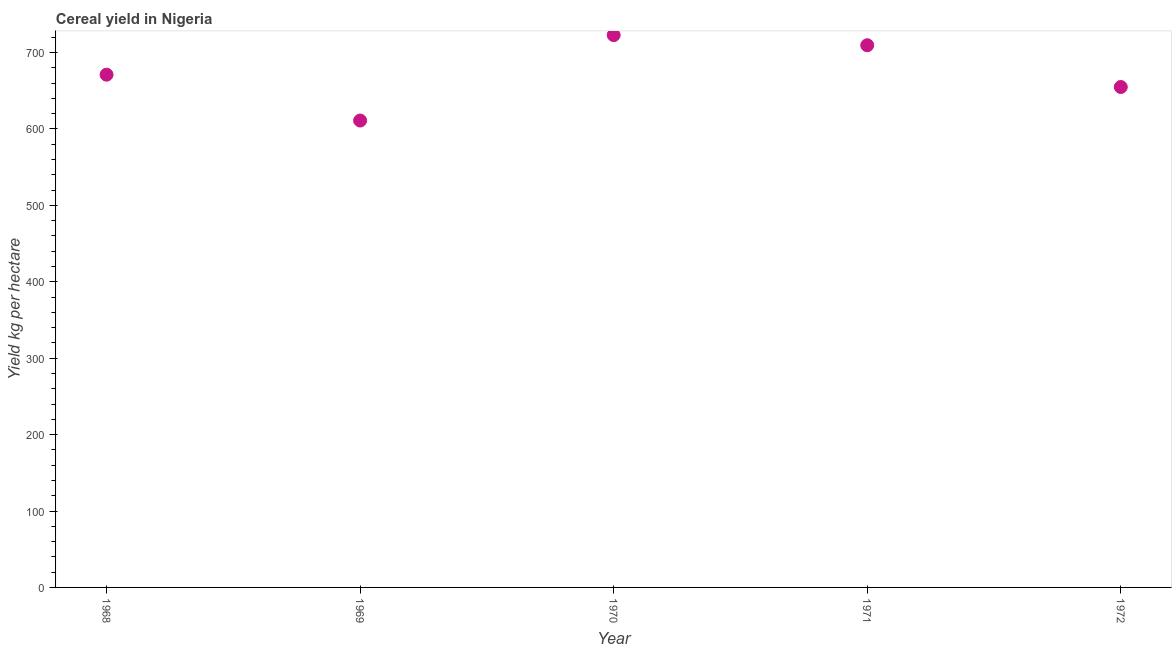What is the cereal yield in 1970?
Keep it short and to the point. 722.88. Across all years, what is the maximum cereal yield?
Provide a succinct answer. 722.88. Across all years, what is the minimum cereal yield?
Offer a terse response. 611.04. In which year was the cereal yield minimum?
Offer a terse response. 1969. What is the sum of the cereal yield?
Your answer should be very brief. 3369.51. What is the difference between the cereal yield in 1968 and 1970?
Provide a short and direct response. -51.8. What is the average cereal yield per year?
Your response must be concise. 673.9. What is the median cereal yield?
Your answer should be very brief. 671.08. Do a majority of the years between 1970 and 1972 (inclusive) have cereal yield greater than 520 kg per hectare?
Provide a short and direct response. Yes. What is the ratio of the cereal yield in 1968 to that in 1969?
Ensure brevity in your answer.  1.1. Is the cereal yield in 1970 less than that in 1972?
Your answer should be very brief. No. Is the difference between the cereal yield in 1971 and 1972 greater than the difference between any two years?
Make the answer very short. No. What is the difference between the highest and the second highest cereal yield?
Ensure brevity in your answer.  13.29. Is the sum of the cereal yield in 1969 and 1970 greater than the maximum cereal yield across all years?
Offer a very short reply. Yes. What is the difference between the highest and the lowest cereal yield?
Your answer should be compact. 111.83. In how many years, is the cereal yield greater than the average cereal yield taken over all years?
Your answer should be compact. 2. Does the cereal yield monotonically increase over the years?
Your answer should be very brief. No. How many years are there in the graph?
Give a very brief answer. 5. What is the difference between two consecutive major ticks on the Y-axis?
Your answer should be compact. 100. Are the values on the major ticks of Y-axis written in scientific E-notation?
Provide a short and direct response. No. Does the graph contain any zero values?
Ensure brevity in your answer.  No. Does the graph contain grids?
Provide a succinct answer. No. What is the title of the graph?
Your answer should be very brief. Cereal yield in Nigeria. What is the label or title of the X-axis?
Your answer should be compact. Year. What is the label or title of the Y-axis?
Your answer should be compact. Yield kg per hectare. What is the Yield kg per hectare in 1968?
Provide a short and direct response. 671.08. What is the Yield kg per hectare in 1969?
Your response must be concise. 611.04. What is the Yield kg per hectare in 1970?
Your response must be concise. 722.88. What is the Yield kg per hectare in 1971?
Ensure brevity in your answer.  709.58. What is the Yield kg per hectare in 1972?
Offer a very short reply. 654.94. What is the difference between the Yield kg per hectare in 1968 and 1969?
Offer a terse response. 60.03. What is the difference between the Yield kg per hectare in 1968 and 1970?
Your answer should be compact. -51.8. What is the difference between the Yield kg per hectare in 1968 and 1971?
Ensure brevity in your answer.  -38.51. What is the difference between the Yield kg per hectare in 1968 and 1972?
Your response must be concise. 16.13. What is the difference between the Yield kg per hectare in 1969 and 1970?
Provide a short and direct response. -111.83. What is the difference between the Yield kg per hectare in 1969 and 1971?
Give a very brief answer. -98.54. What is the difference between the Yield kg per hectare in 1969 and 1972?
Your answer should be compact. -43.9. What is the difference between the Yield kg per hectare in 1970 and 1971?
Make the answer very short. 13.29. What is the difference between the Yield kg per hectare in 1970 and 1972?
Ensure brevity in your answer.  67.93. What is the difference between the Yield kg per hectare in 1971 and 1972?
Your answer should be very brief. 54.64. What is the ratio of the Yield kg per hectare in 1968 to that in 1969?
Your response must be concise. 1.1. What is the ratio of the Yield kg per hectare in 1968 to that in 1970?
Ensure brevity in your answer.  0.93. What is the ratio of the Yield kg per hectare in 1968 to that in 1971?
Provide a succinct answer. 0.95. What is the ratio of the Yield kg per hectare in 1969 to that in 1970?
Make the answer very short. 0.84. What is the ratio of the Yield kg per hectare in 1969 to that in 1971?
Provide a succinct answer. 0.86. What is the ratio of the Yield kg per hectare in 1969 to that in 1972?
Keep it short and to the point. 0.93. What is the ratio of the Yield kg per hectare in 1970 to that in 1971?
Offer a very short reply. 1.02. What is the ratio of the Yield kg per hectare in 1970 to that in 1972?
Give a very brief answer. 1.1. What is the ratio of the Yield kg per hectare in 1971 to that in 1972?
Ensure brevity in your answer.  1.08. 